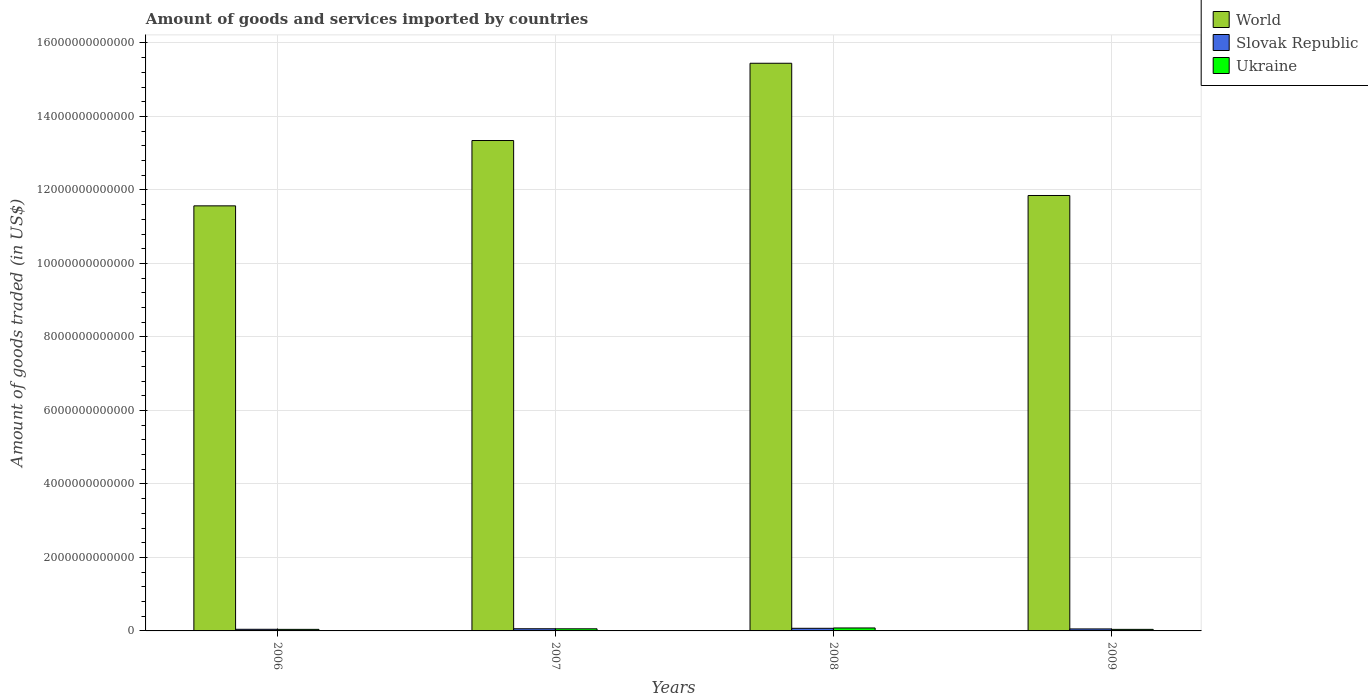Are the number of bars on each tick of the X-axis equal?
Offer a very short reply. Yes. How many bars are there on the 1st tick from the left?
Keep it short and to the point. 3. In how many cases, is the number of bars for a given year not equal to the number of legend labels?
Give a very brief answer. 0. What is the total amount of goods and services imported in Ukraine in 2007?
Provide a short and direct response. 5.78e+1. Across all years, what is the maximum total amount of goods and services imported in World?
Your response must be concise. 1.54e+13. Across all years, what is the minimum total amount of goods and services imported in World?
Your answer should be compact. 1.16e+13. In which year was the total amount of goods and services imported in World maximum?
Keep it short and to the point. 2008. In which year was the total amount of goods and services imported in Slovak Republic minimum?
Give a very brief answer. 2006. What is the total total amount of goods and services imported in Slovak Republic in the graph?
Offer a terse response. 2.28e+11. What is the difference between the total amount of goods and services imported in Slovak Republic in 2006 and that in 2009?
Provide a succinct answer. -9.86e+09. What is the difference between the total amount of goods and services imported in Slovak Republic in 2008 and the total amount of goods and services imported in World in 2009?
Make the answer very short. -1.18e+13. What is the average total amount of goods and services imported in Ukraine per year?
Give a very brief answer. 5.58e+1. In the year 2008, what is the difference between the total amount of goods and services imported in World and total amount of goods and services imported in Slovak Republic?
Provide a succinct answer. 1.54e+13. In how many years, is the total amount of goods and services imported in Ukraine greater than 14400000000000 US$?
Keep it short and to the point. 0. What is the ratio of the total amount of goods and services imported in Ukraine in 2008 to that in 2009?
Your answer should be very brief. 1.9. Is the total amount of goods and services imported in Ukraine in 2008 less than that in 2009?
Keep it short and to the point. No. Is the difference between the total amount of goods and services imported in World in 2007 and 2008 greater than the difference between the total amount of goods and services imported in Slovak Republic in 2007 and 2008?
Ensure brevity in your answer.  No. What is the difference between the highest and the second highest total amount of goods and services imported in Ukraine?
Your response must be concise. 2.29e+1. What is the difference between the highest and the lowest total amount of goods and services imported in Ukraine?
Your response must be concise. 3.84e+1. In how many years, is the total amount of goods and services imported in Ukraine greater than the average total amount of goods and services imported in Ukraine taken over all years?
Offer a terse response. 2. Is the sum of the total amount of goods and services imported in Slovak Republic in 2008 and 2009 greater than the maximum total amount of goods and services imported in World across all years?
Ensure brevity in your answer.  No. What does the 3rd bar from the left in 2009 represents?
Offer a terse response. Ukraine. What does the 1st bar from the right in 2008 represents?
Provide a succinct answer. Ukraine. Is it the case that in every year, the sum of the total amount of goods and services imported in Ukraine and total amount of goods and services imported in Slovak Republic is greater than the total amount of goods and services imported in World?
Offer a very short reply. No. How many years are there in the graph?
Provide a succinct answer. 4. What is the difference between two consecutive major ticks on the Y-axis?
Your answer should be very brief. 2.00e+12. Does the graph contain any zero values?
Offer a very short reply. No. How are the legend labels stacked?
Your response must be concise. Vertical. What is the title of the graph?
Offer a terse response. Amount of goods and services imported by countries. What is the label or title of the X-axis?
Your answer should be compact. Years. What is the label or title of the Y-axis?
Keep it short and to the point. Amount of goods traded (in US$). What is the Amount of goods traded (in US$) of World in 2006?
Offer a terse response. 1.16e+13. What is the Amount of goods traded (in US$) in Slovak Republic in 2006?
Your answer should be compact. 4.43e+1. What is the Amount of goods traded (in US$) of Ukraine in 2006?
Keep it short and to the point. 4.22e+1. What is the Amount of goods traded (in US$) in World in 2007?
Ensure brevity in your answer.  1.33e+13. What is the Amount of goods traded (in US$) of Slovak Republic in 2007?
Your response must be concise. 5.87e+1. What is the Amount of goods traded (in US$) in Ukraine in 2007?
Keep it short and to the point. 5.78e+1. What is the Amount of goods traded (in US$) in World in 2008?
Offer a very short reply. 1.54e+13. What is the Amount of goods traded (in US$) of Slovak Republic in 2008?
Give a very brief answer. 7.12e+1. What is the Amount of goods traded (in US$) in Ukraine in 2008?
Your response must be concise. 8.06e+1. What is the Amount of goods traded (in US$) of World in 2009?
Offer a very short reply. 1.18e+13. What is the Amount of goods traded (in US$) in Slovak Republic in 2009?
Provide a succinct answer. 5.41e+1. What is the Amount of goods traded (in US$) in Ukraine in 2009?
Provide a short and direct response. 4.25e+1. Across all years, what is the maximum Amount of goods traded (in US$) in World?
Keep it short and to the point. 1.54e+13. Across all years, what is the maximum Amount of goods traded (in US$) in Slovak Republic?
Keep it short and to the point. 7.12e+1. Across all years, what is the maximum Amount of goods traded (in US$) of Ukraine?
Provide a succinct answer. 8.06e+1. Across all years, what is the minimum Amount of goods traded (in US$) of World?
Provide a succinct answer. 1.16e+13. Across all years, what is the minimum Amount of goods traded (in US$) of Slovak Republic?
Your answer should be compact. 4.43e+1. Across all years, what is the minimum Amount of goods traded (in US$) in Ukraine?
Provide a succinct answer. 4.22e+1. What is the total Amount of goods traded (in US$) of World in the graph?
Ensure brevity in your answer.  5.22e+13. What is the total Amount of goods traded (in US$) in Slovak Republic in the graph?
Offer a very short reply. 2.28e+11. What is the total Amount of goods traded (in US$) in Ukraine in the graph?
Give a very brief answer. 2.23e+11. What is the difference between the Amount of goods traded (in US$) in World in 2006 and that in 2007?
Keep it short and to the point. -1.78e+12. What is the difference between the Amount of goods traded (in US$) of Slovak Republic in 2006 and that in 2007?
Offer a very short reply. -1.44e+1. What is the difference between the Amount of goods traded (in US$) in Ukraine in 2006 and that in 2007?
Your answer should be compact. -1.55e+1. What is the difference between the Amount of goods traded (in US$) in World in 2006 and that in 2008?
Give a very brief answer. -3.88e+12. What is the difference between the Amount of goods traded (in US$) of Slovak Republic in 2006 and that in 2008?
Ensure brevity in your answer.  -2.69e+1. What is the difference between the Amount of goods traded (in US$) in Ukraine in 2006 and that in 2008?
Make the answer very short. -3.84e+1. What is the difference between the Amount of goods traded (in US$) of World in 2006 and that in 2009?
Provide a succinct answer. -2.82e+11. What is the difference between the Amount of goods traded (in US$) of Slovak Republic in 2006 and that in 2009?
Offer a terse response. -9.86e+09. What is the difference between the Amount of goods traded (in US$) in Ukraine in 2006 and that in 2009?
Give a very brief answer. -2.57e+08. What is the difference between the Amount of goods traded (in US$) of World in 2007 and that in 2008?
Offer a terse response. -2.10e+12. What is the difference between the Amount of goods traded (in US$) in Slovak Republic in 2007 and that in 2008?
Your response must be concise. -1.25e+1. What is the difference between the Amount of goods traded (in US$) in Ukraine in 2007 and that in 2008?
Keep it short and to the point. -2.29e+1. What is the difference between the Amount of goods traded (in US$) of World in 2007 and that in 2009?
Your answer should be compact. 1.50e+12. What is the difference between the Amount of goods traded (in US$) in Slovak Republic in 2007 and that in 2009?
Your answer should be very brief. 4.57e+09. What is the difference between the Amount of goods traded (in US$) in Ukraine in 2007 and that in 2009?
Offer a very short reply. 1.53e+1. What is the difference between the Amount of goods traded (in US$) of World in 2008 and that in 2009?
Offer a very short reply. 3.60e+12. What is the difference between the Amount of goods traded (in US$) in Slovak Republic in 2008 and that in 2009?
Make the answer very short. 1.70e+1. What is the difference between the Amount of goods traded (in US$) of Ukraine in 2008 and that in 2009?
Provide a succinct answer. 3.82e+1. What is the difference between the Amount of goods traded (in US$) in World in 2006 and the Amount of goods traded (in US$) in Slovak Republic in 2007?
Your response must be concise. 1.15e+13. What is the difference between the Amount of goods traded (in US$) of World in 2006 and the Amount of goods traded (in US$) of Ukraine in 2007?
Provide a succinct answer. 1.15e+13. What is the difference between the Amount of goods traded (in US$) in Slovak Republic in 2006 and the Amount of goods traded (in US$) in Ukraine in 2007?
Provide a short and direct response. -1.35e+1. What is the difference between the Amount of goods traded (in US$) of World in 2006 and the Amount of goods traded (in US$) of Slovak Republic in 2008?
Your answer should be very brief. 1.15e+13. What is the difference between the Amount of goods traded (in US$) of World in 2006 and the Amount of goods traded (in US$) of Ukraine in 2008?
Provide a short and direct response. 1.15e+13. What is the difference between the Amount of goods traded (in US$) in Slovak Republic in 2006 and the Amount of goods traded (in US$) in Ukraine in 2008?
Offer a very short reply. -3.64e+1. What is the difference between the Amount of goods traded (in US$) of World in 2006 and the Amount of goods traded (in US$) of Slovak Republic in 2009?
Your response must be concise. 1.15e+13. What is the difference between the Amount of goods traded (in US$) in World in 2006 and the Amount of goods traded (in US$) in Ukraine in 2009?
Make the answer very short. 1.15e+13. What is the difference between the Amount of goods traded (in US$) in Slovak Republic in 2006 and the Amount of goods traded (in US$) in Ukraine in 2009?
Your response must be concise. 1.81e+09. What is the difference between the Amount of goods traded (in US$) of World in 2007 and the Amount of goods traded (in US$) of Slovak Republic in 2008?
Make the answer very short. 1.33e+13. What is the difference between the Amount of goods traded (in US$) of World in 2007 and the Amount of goods traded (in US$) of Ukraine in 2008?
Ensure brevity in your answer.  1.33e+13. What is the difference between the Amount of goods traded (in US$) of Slovak Republic in 2007 and the Amount of goods traded (in US$) of Ukraine in 2008?
Offer a very short reply. -2.19e+1. What is the difference between the Amount of goods traded (in US$) in World in 2007 and the Amount of goods traded (in US$) in Slovak Republic in 2009?
Your answer should be compact. 1.33e+13. What is the difference between the Amount of goods traded (in US$) of World in 2007 and the Amount of goods traded (in US$) of Ukraine in 2009?
Offer a terse response. 1.33e+13. What is the difference between the Amount of goods traded (in US$) in Slovak Republic in 2007 and the Amount of goods traded (in US$) in Ukraine in 2009?
Give a very brief answer. 1.62e+1. What is the difference between the Amount of goods traded (in US$) in World in 2008 and the Amount of goods traded (in US$) in Slovak Republic in 2009?
Your response must be concise. 1.54e+13. What is the difference between the Amount of goods traded (in US$) in World in 2008 and the Amount of goods traded (in US$) in Ukraine in 2009?
Offer a terse response. 1.54e+13. What is the difference between the Amount of goods traded (in US$) of Slovak Republic in 2008 and the Amount of goods traded (in US$) of Ukraine in 2009?
Offer a very short reply. 2.87e+1. What is the average Amount of goods traded (in US$) of World per year?
Provide a short and direct response. 1.31e+13. What is the average Amount of goods traded (in US$) in Slovak Republic per year?
Your answer should be compact. 5.71e+1. What is the average Amount of goods traded (in US$) in Ukraine per year?
Offer a terse response. 5.58e+1. In the year 2006, what is the difference between the Amount of goods traded (in US$) of World and Amount of goods traded (in US$) of Slovak Republic?
Give a very brief answer. 1.15e+13. In the year 2006, what is the difference between the Amount of goods traded (in US$) of World and Amount of goods traded (in US$) of Ukraine?
Provide a short and direct response. 1.15e+13. In the year 2006, what is the difference between the Amount of goods traded (in US$) of Slovak Republic and Amount of goods traded (in US$) of Ukraine?
Your response must be concise. 2.06e+09. In the year 2007, what is the difference between the Amount of goods traded (in US$) of World and Amount of goods traded (in US$) of Slovak Republic?
Offer a terse response. 1.33e+13. In the year 2007, what is the difference between the Amount of goods traded (in US$) of World and Amount of goods traded (in US$) of Ukraine?
Offer a terse response. 1.33e+13. In the year 2007, what is the difference between the Amount of goods traded (in US$) in Slovak Republic and Amount of goods traded (in US$) in Ukraine?
Make the answer very short. 9.62e+08. In the year 2008, what is the difference between the Amount of goods traded (in US$) in World and Amount of goods traded (in US$) in Slovak Republic?
Provide a succinct answer. 1.54e+13. In the year 2008, what is the difference between the Amount of goods traded (in US$) of World and Amount of goods traded (in US$) of Ukraine?
Your response must be concise. 1.54e+13. In the year 2008, what is the difference between the Amount of goods traded (in US$) of Slovak Republic and Amount of goods traded (in US$) of Ukraine?
Ensure brevity in your answer.  -9.47e+09. In the year 2009, what is the difference between the Amount of goods traded (in US$) of World and Amount of goods traded (in US$) of Slovak Republic?
Provide a succinct answer. 1.18e+13. In the year 2009, what is the difference between the Amount of goods traded (in US$) in World and Amount of goods traded (in US$) in Ukraine?
Offer a very short reply. 1.18e+13. In the year 2009, what is the difference between the Amount of goods traded (in US$) in Slovak Republic and Amount of goods traded (in US$) in Ukraine?
Give a very brief answer. 1.17e+1. What is the ratio of the Amount of goods traded (in US$) in World in 2006 to that in 2007?
Offer a terse response. 0.87. What is the ratio of the Amount of goods traded (in US$) in Slovak Republic in 2006 to that in 2007?
Keep it short and to the point. 0.75. What is the ratio of the Amount of goods traded (in US$) of Ukraine in 2006 to that in 2007?
Your answer should be very brief. 0.73. What is the ratio of the Amount of goods traded (in US$) of World in 2006 to that in 2008?
Give a very brief answer. 0.75. What is the ratio of the Amount of goods traded (in US$) of Slovak Republic in 2006 to that in 2008?
Provide a short and direct response. 0.62. What is the ratio of the Amount of goods traded (in US$) in Ukraine in 2006 to that in 2008?
Your answer should be compact. 0.52. What is the ratio of the Amount of goods traded (in US$) in World in 2006 to that in 2009?
Offer a very short reply. 0.98. What is the ratio of the Amount of goods traded (in US$) in Slovak Republic in 2006 to that in 2009?
Keep it short and to the point. 0.82. What is the ratio of the Amount of goods traded (in US$) of World in 2007 to that in 2008?
Give a very brief answer. 0.86. What is the ratio of the Amount of goods traded (in US$) of Slovak Republic in 2007 to that in 2008?
Offer a very short reply. 0.82. What is the ratio of the Amount of goods traded (in US$) of Ukraine in 2007 to that in 2008?
Your answer should be compact. 0.72. What is the ratio of the Amount of goods traded (in US$) in World in 2007 to that in 2009?
Provide a short and direct response. 1.13. What is the ratio of the Amount of goods traded (in US$) in Slovak Republic in 2007 to that in 2009?
Give a very brief answer. 1.08. What is the ratio of the Amount of goods traded (in US$) in Ukraine in 2007 to that in 2009?
Offer a terse response. 1.36. What is the ratio of the Amount of goods traded (in US$) in World in 2008 to that in 2009?
Provide a succinct answer. 1.3. What is the ratio of the Amount of goods traded (in US$) in Slovak Republic in 2008 to that in 2009?
Offer a terse response. 1.31. What is the ratio of the Amount of goods traded (in US$) in Ukraine in 2008 to that in 2009?
Your answer should be very brief. 1.9. What is the difference between the highest and the second highest Amount of goods traded (in US$) of World?
Provide a short and direct response. 2.10e+12. What is the difference between the highest and the second highest Amount of goods traded (in US$) of Slovak Republic?
Your answer should be compact. 1.25e+1. What is the difference between the highest and the second highest Amount of goods traded (in US$) in Ukraine?
Make the answer very short. 2.29e+1. What is the difference between the highest and the lowest Amount of goods traded (in US$) in World?
Give a very brief answer. 3.88e+12. What is the difference between the highest and the lowest Amount of goods traded (in US$) of Slovak Republic?
Provide a succinct answer. 2.69e+1. What is the difference between the highest and the lowest Amount of goods traded (in US$) of Ukraine?
Give a very brief answer. 3.84e+1. 